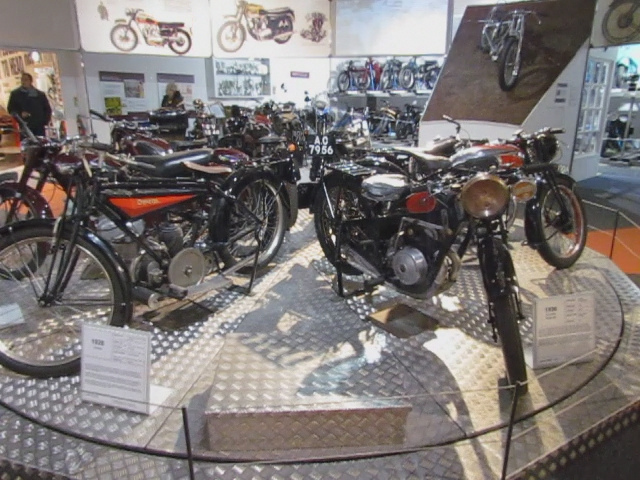What kind of people would be interested in this motorcycle collection? This collection would attract a diverse group of individuals, from die-hard motorcycle enthusiasts and collectors to historians interested in the technological advancements and design trends of the past. It's also a great place for casual visitors who appreciate mechanical engineering and industrial design. 